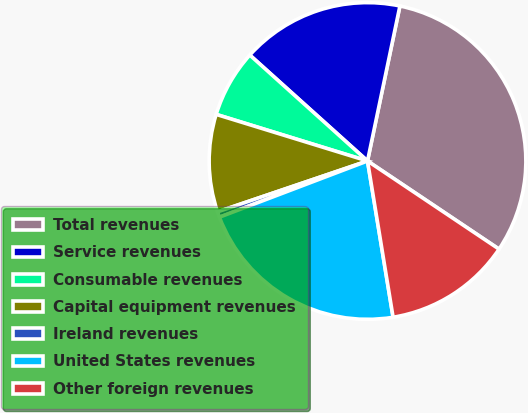Convert chart. <chart><loc_0><loc_0><loc_500><loc_500><pie_chart><fcel>Total revenues<fcel>Service revenues<fcel>Consumable revenues<fcel>Capital equipment revenues<fcel>Ireland revenues<fcel>United States revenues<fcel>Other foreign revenues<nl><fcel>31.12%<fcel>16.62%<fcel>6.91%<fcel>9.96%<fcel>0.57%<fcel>21.81%<fcel>13.02%<nl></chart> 